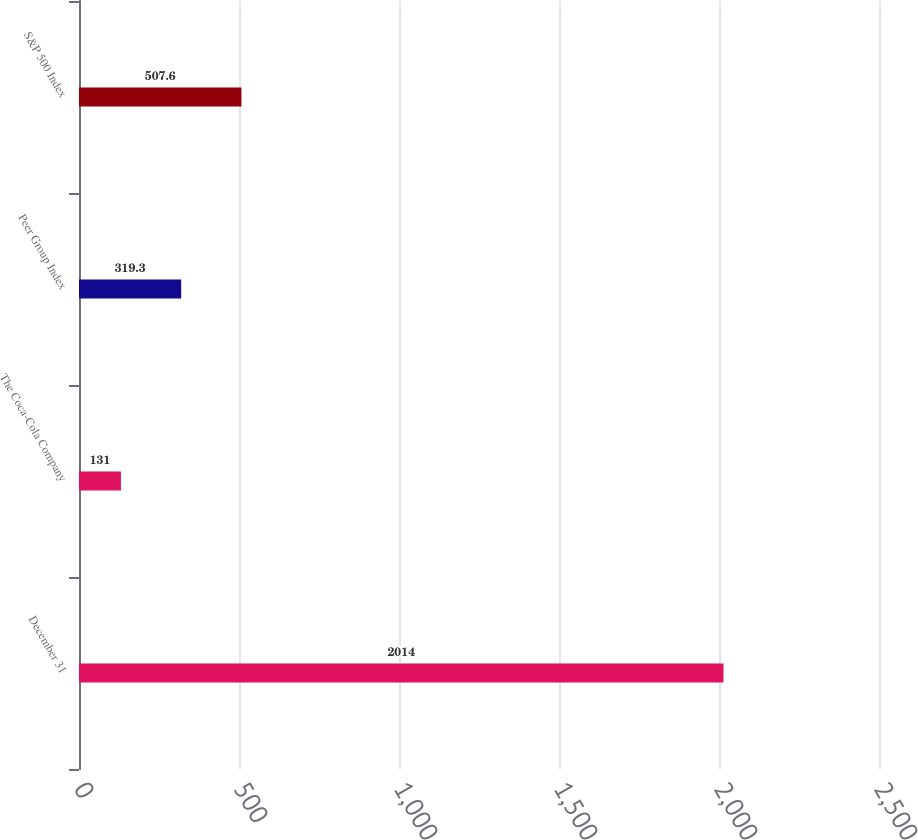Convert chart. <chart><loc_0><loc_0><loc_500><loc_500><bar_chart><fcel>December 31<fcel>The Coca-Cola Company<fcel>Peer Group Index<fcel>S&P 500 Index<nl><fcel>2014<fcel>131<fcel>319.3<fcel>507.6<nl></chart> 